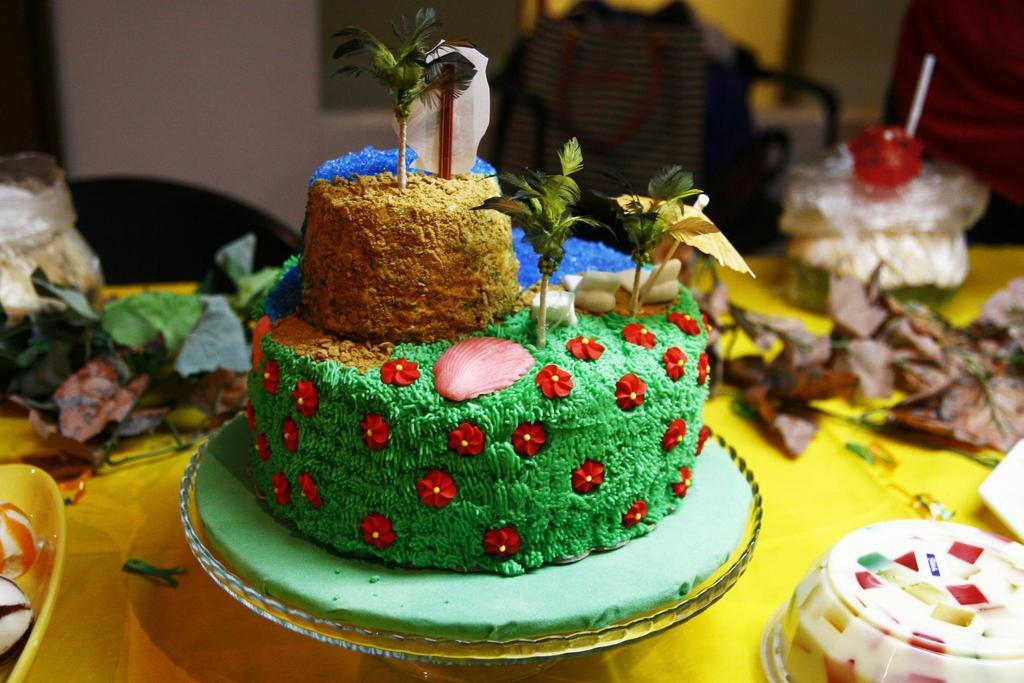What type of food can be seen in the image? There are desserts in the image. What additional items are present in the image besides desserts? There are decor items, bowls, and other objects on the table in the image. What can be seen in the background of the image? There is a cloth, a wall, and a person in the background of the image. How many animals are visible in the image? There are no animals visible in the image. What is the person in the background of the image doing, and what is the sound they are making? There is no information about the person's actions or sounds in the image. 